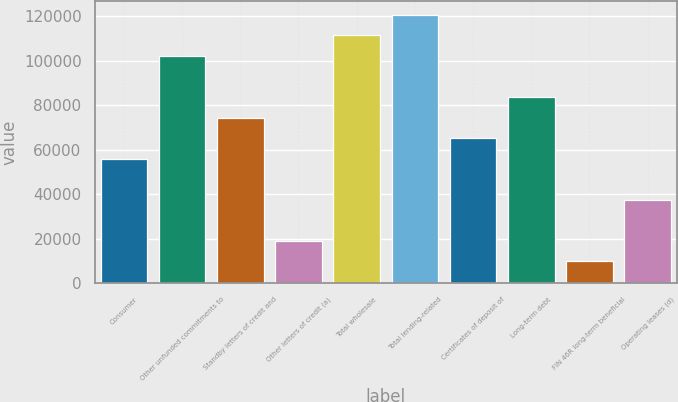Convert chart. <chart><loc_0><loc_0><loc_500><loc_500><bar_chart><fcel>Consumer<fcel>Other unfunded commitments to<fcel>Standby letters of credit and<fcel>Other letters of credit (a)<fcel>Total wholesale<fcel>Total lending-related<fcel>Certificates of deposit of<fcel>Long-term debt<fcel>FIN 46R long-term beneficial<fcel>Operating leases (d)<nl><fcel>55940<fcel>102125<fcel>74414<fcel>18992<fcel>111362<fcel>120599<fcel>65177<fcel>83651<fcel>9755<fcel>37466<nl></chart> 